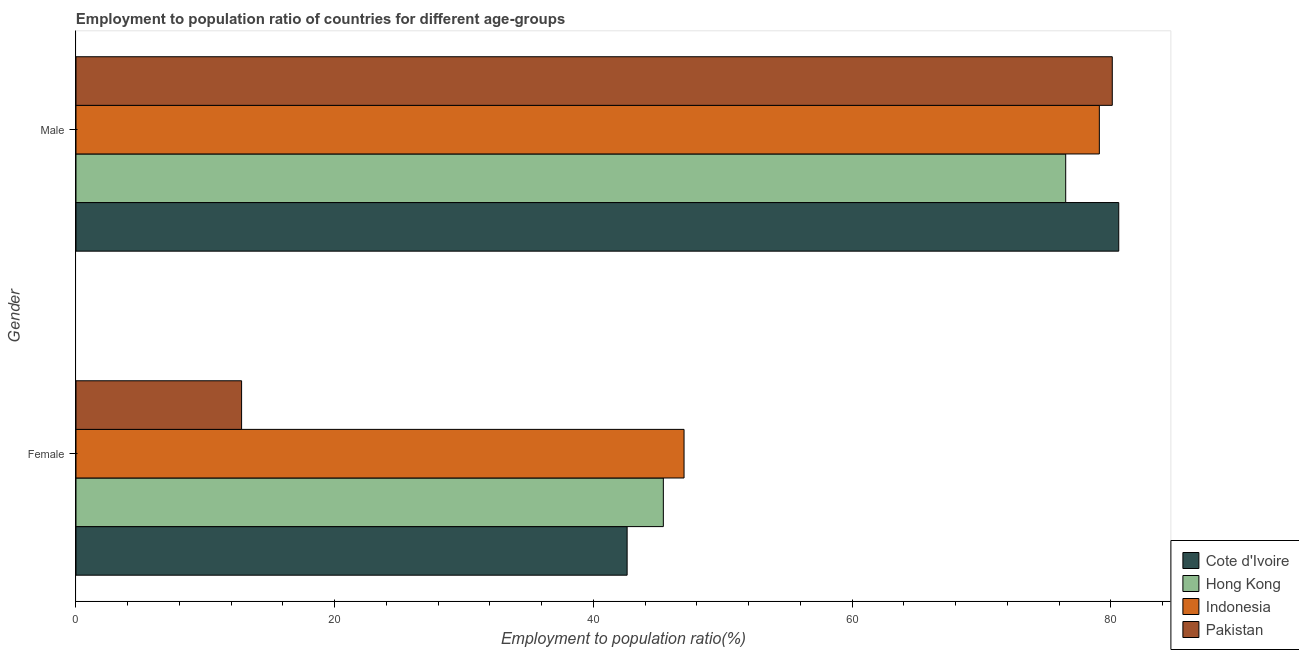How many groups of bars are there?
Your answer should be very brief. 2. Are the number of bars per tick equal to the number of legend labels?
Offer a very short reply. Yes. Are the number of bars on each tick of the Y-axis equal?
Provide a short and direct response. Yes. How many bars are there on the 1st tick from the top?
Make the answer very short. 4. What is the label of the 1st group of bars from the top?
Offer a very short reply. Male. What is the employment to population ratio(female) in Cote d'Ivoire?
Your answer should be very brief. 42.6. Across all countries, what is the maximum employment to population ratio(male)?
Offer a very short reply. 80.6. Across all countries, what is the minimum employment to population ratio(male)?
Your answer should be very brief. 76.5. In which country was the employment to population ratio(female) maximum?
Give a very brief answer. Indonesia. What is the total employment to population ratio(female) in the graph?
Provide a short and direct response. 147.8. What is the difference between the employment to population ratio(female) in Indonesia and the employment to population ratio(male) in Cote d'Ivoire?
Keep it short and to the point. -33.6. What is the average employment to population ratio(male) per country?
Offer a terse response. 79.07. What is the difference between the employment to population ratio(male) and employment to population ratio(female) in Indonesia?
Provide a succinct answer. 32.1. In how many countries, is the employment to population ratio(female) greater than 60 %?
Offer a terse response. 0. What is the ratio of the employment to population ratio(female) in Indonesia to that in Cote d'Ivoire?
Provide a succinct answer. 1.1. Is the employment to population ratio(female) in Cote d'Ivoire less than that in Pakistan?
Keep it short and to the point. No. In how many countries, is the employment to population ratio(male) greater than the average employment to population ratio(male) taken over all countries?
Your response must be concise. 3. What does the 1st bar from the top in Female represents?
Offer a very short reply. Pakistan. Are all the bars in the graph horizontal?
Provide a succinct answer. Yes. Are the values on the major ticks of X-axis written in scientific E-notation?
Offer a terse response. No. How many legend labels are there?
Provide a short and direct response. 4. What is the title of the graph?
Keep it short and to the point. Employment to population ratio of countries for different age-groups. Does "Pakistan" appear as one of the legend labels in the graph?
Ensure brevity in your answer.  Yes. What is the label or title of the Y-axis?
Provide a short and direct response. Gender. What is the Employment to population ratio(%) of Cote d'Ivoire in Female?
Give a very brief answer. 42.6. What is the Employment to population ratio(%) in Hong Kong in Female?
Your answer should be compact. 45.4. What is the Employment to population ratio(%) of Indonesia in Female?
Provide a short and direct response. 47. What is the Employment to population ratio(%) of Pakistan in Female?
Provide a succinct answer. 12.8. What is the Employment to population ratio(%) of Cote d'Ivoire in Male?
Offer a very short reply. 80.6. What is the Employment to population ratio(%) in Hong Kong in Male?
Provide a succinct answer. 76.5. What is the Employment to population ratio(%) in Indonesia in Male?
Offer a very short reply. 79.1. What is the Employment to population ratio(%) in Pakistan in Male?
Make the answer very short. 80.1. Across all Gender, what is the maximum Employment to population ratio(%) in Cote d'Ivoire?
Offer a very short reply. 80.6. Across all Gender, what is the maximum Employment to population ratio(%) in Hong Kong?
Your answer should be compact. 76.5. Across all Gender, what is the maximum Employment to population ratio(%) of Indonesia?
Offer a very short reply. 79.1. Across all Gender, what is the maximum Employment to population ratio(%) in Pakistan?
Your answer should be very brief. 80.1. Across all Gender, what is the minimum Employment to population ratio(%) of Cote d'Ivoire?
Offer a very short reply. 42.6. Across all Gender, what is the minimum Employment to population ratio(%) in Hong Kong?
Offer a terse response. 45.4. Across all Gender, what is the minimum Employment to population ratio(%) of Indonesia?
Your response must be concise. 47. Across all Gender, what is the minimum Employment to population ratio(%) in Pakistan?
Offer a very short reply. 12.8. What is the total Employment to population ratio(%) of Cote d'Ivoire in the graph?
Offer a terse response. 123.2. What is the total Employment to population ratio(%) of Hong Kong in the graph?
Provide a succinct answer. 121.9. What is the total Employment to population ratio(%) in Indonesia in the graph?
Offer a terse response. 126.1. What is the total Employment to population ratio(%) in Pakistan in the graph?
Provide a succinct answer. 92.9. What is the difference between the Employment to population ratio(%) in Cote d'Ivoire in Female and that in Male?
Your response must be concise. -38. What is the difference between the Employment to population ratio(%) in Hong Kong in Female and that in Male?
Offer a terse response. -31.1. What is the difference between the Employment to population ratio(%) in Indonesia in Female and that in Male?
Ensure brevity in your answer.  -32.1. What is the difference between the Employment to population ratio(%) of Pakistan in Female and that in Male?
Provide a short and direct response. -67.3. What is the difference between the Employment to population ratio(%) of Cote d'Ivoire in Female and the Employment to population ratio(%) of Hong Kong in Male?
Your answer should be very brief. -33.9. What is the difference between the Employment to population ratio(%) of Cote d'Ivoire in Female and the Employment to population ratio(%) of Indonesia in Male?
Your answer should be compact. -36.5. What is the difference between the Employment to population ratio(%) of Cote d'Ivoire in Female and the Employment to population ratio(%) of Pakistan in Male?
Make the answer very short. -37.5. What is the difference between the Employment to population ratio(%) in Hong Kong in Female and the Employment to population ratio(%) in Indonesia in Male?
Offer a terse response. -33.7. What is the difference between the Employment to population ratio(%) of Hong Kong in Female and the Employment to population ratio(%) of Pakistan in Male?
Offer a terse response. -34.7. What is the difference between the Employment to population ratio(%) of Indonesia in Female and the Employment to population ratio(%) of Pakistan in Male?
Keep it short and to the point. -33.1. What is the average Employment to population ratio(%) of Cote d'Ivoire per Gender?
Ensure brevity in your answer.  61.6. What is the average Employment to population ratio(%) in Hong Kong per Gender?
Make the answer very short. 60.95. What is the average Employment to population ratio(%) of Indonesia per Gender?
Offer a very short reply. 63.05. What is the average Employment to population ratio(%) of Pakistan per Gender?
Provide a short and direct response. 46.45. What is the difference between the Employment to population ratio(%) in Cote d'Ivoire and Employment to population ratio(%) in Hong Kong in Female?
Your answer should be very brief. -2.8. What is the difference between the Employment to population ratio(%) of Cote d'Ivoire and Employment to population ratio(%) of Indonesia in Female?
Your response must be concise. -4.4. What is the difference between the Employment to population ratio(%) of Cote d'Ivoire and Employment to population ratio(%) of Pakistan in Female?
Your response must be concise. 29.8. What is the difference between the Employment to population ratio(%) in Hong Kong and Employment to population ratio(%) in Pakistan in Female?
Offer a very short reply. 32.6. What is the difference between the Employment to population ratio(%) of Indonesia and Employment to population ratio(%) of Pakistan in Female?
Provide a succinct answer. 34.2. What is the difference between the Employment to population ratio(%) in Cote d'Ivoire and Employment to population ratio(%) in Indonesia in Male?
Provide a short and direct response. 1.5. What is the difference between the Employment to population ratio(%) in Cote d'Ivoire and Employment to population ratio(%) in Pakistan in Male?
Offer a terse response. 0.5. What is the difference between the Employment to population ratio(%) in Hong Kong and Employment to population ratio(%) in Indonesia in Male?
Your response must be concise. -2.6. What is the ratio of the Employment to population ratio(%) of Cote d'Ivoire in Female to that in Male?
Offer a terse response. 0.53. What is the ratio of the Employment to population ratio(%) in Hong Kong in Female to that in Male?
Your answer should be compact. 0.59. What is the ratio of the Employment to population ratio(%) in Indonesia in Female to that in Male?
Ensure brevity in your answer.  0.59. What is the ratio of the Employment to population ratio(%) in Pakistan in Female to that in Male?
Your response must be concise. 0.16. What is the difference between the highest and the second highest Employment to population ratio(%) of Cote d'Ivoire?
Provide a short and direct response. 38. What is the difference between the highest and the second highest Employment to population ratio(%) in Hong Kong?
Provide a succinct answer. 31.1. What is the difference between the highest and the second highest Employment to population ratio(%) in Indonesia?
Give a very brief answer. 32.1. What is the difference between the highest and the second highest Employment to population ratio(%) in Pakistan?
Offer a very short reply. 67.3. What is the difference between the highest and the lowest Employment to population ratio(%) in Hong Kong?
Ensure brevity in your answer.  31.1. What is the difference between the highest and the lowest Employment to population ratio(%) in Indonesia?
Give a very brief answer. 32.1. What is the difference between the highest and the lowest Employment to population ratio(%) of Pakistan?
Offer a very short reply. 67.3. 